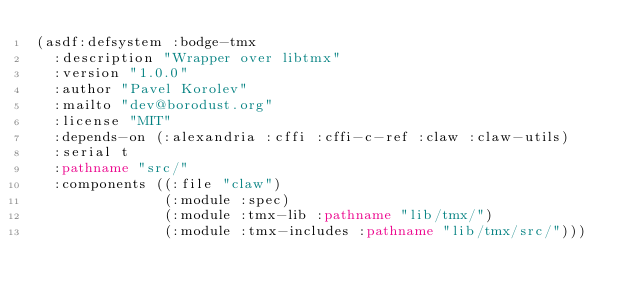Convert code to text. <code><loc_0><loc_0><loc_500><loc_500><_Lisp_>(asdf:defsystem :bodge-tmx
  :description "Wrapper over libtmx"
  :version "1.0.0"
  :author "Pavel Korolev"
  :mailto "dev@borodust.org"
  :license "MIT"
  :depends-on (:alexandria :cffi :cffi-c-ref :claw :claw-utils)
  :serial t
  :pathname "src/"
  :components ((:file "claw")
               (:module :spec)
               (:module :tmx-lib :pathname "lib/tmx/")
               (:module :tmx-includes :pathname "lib/tmx/src/")))
</code> 